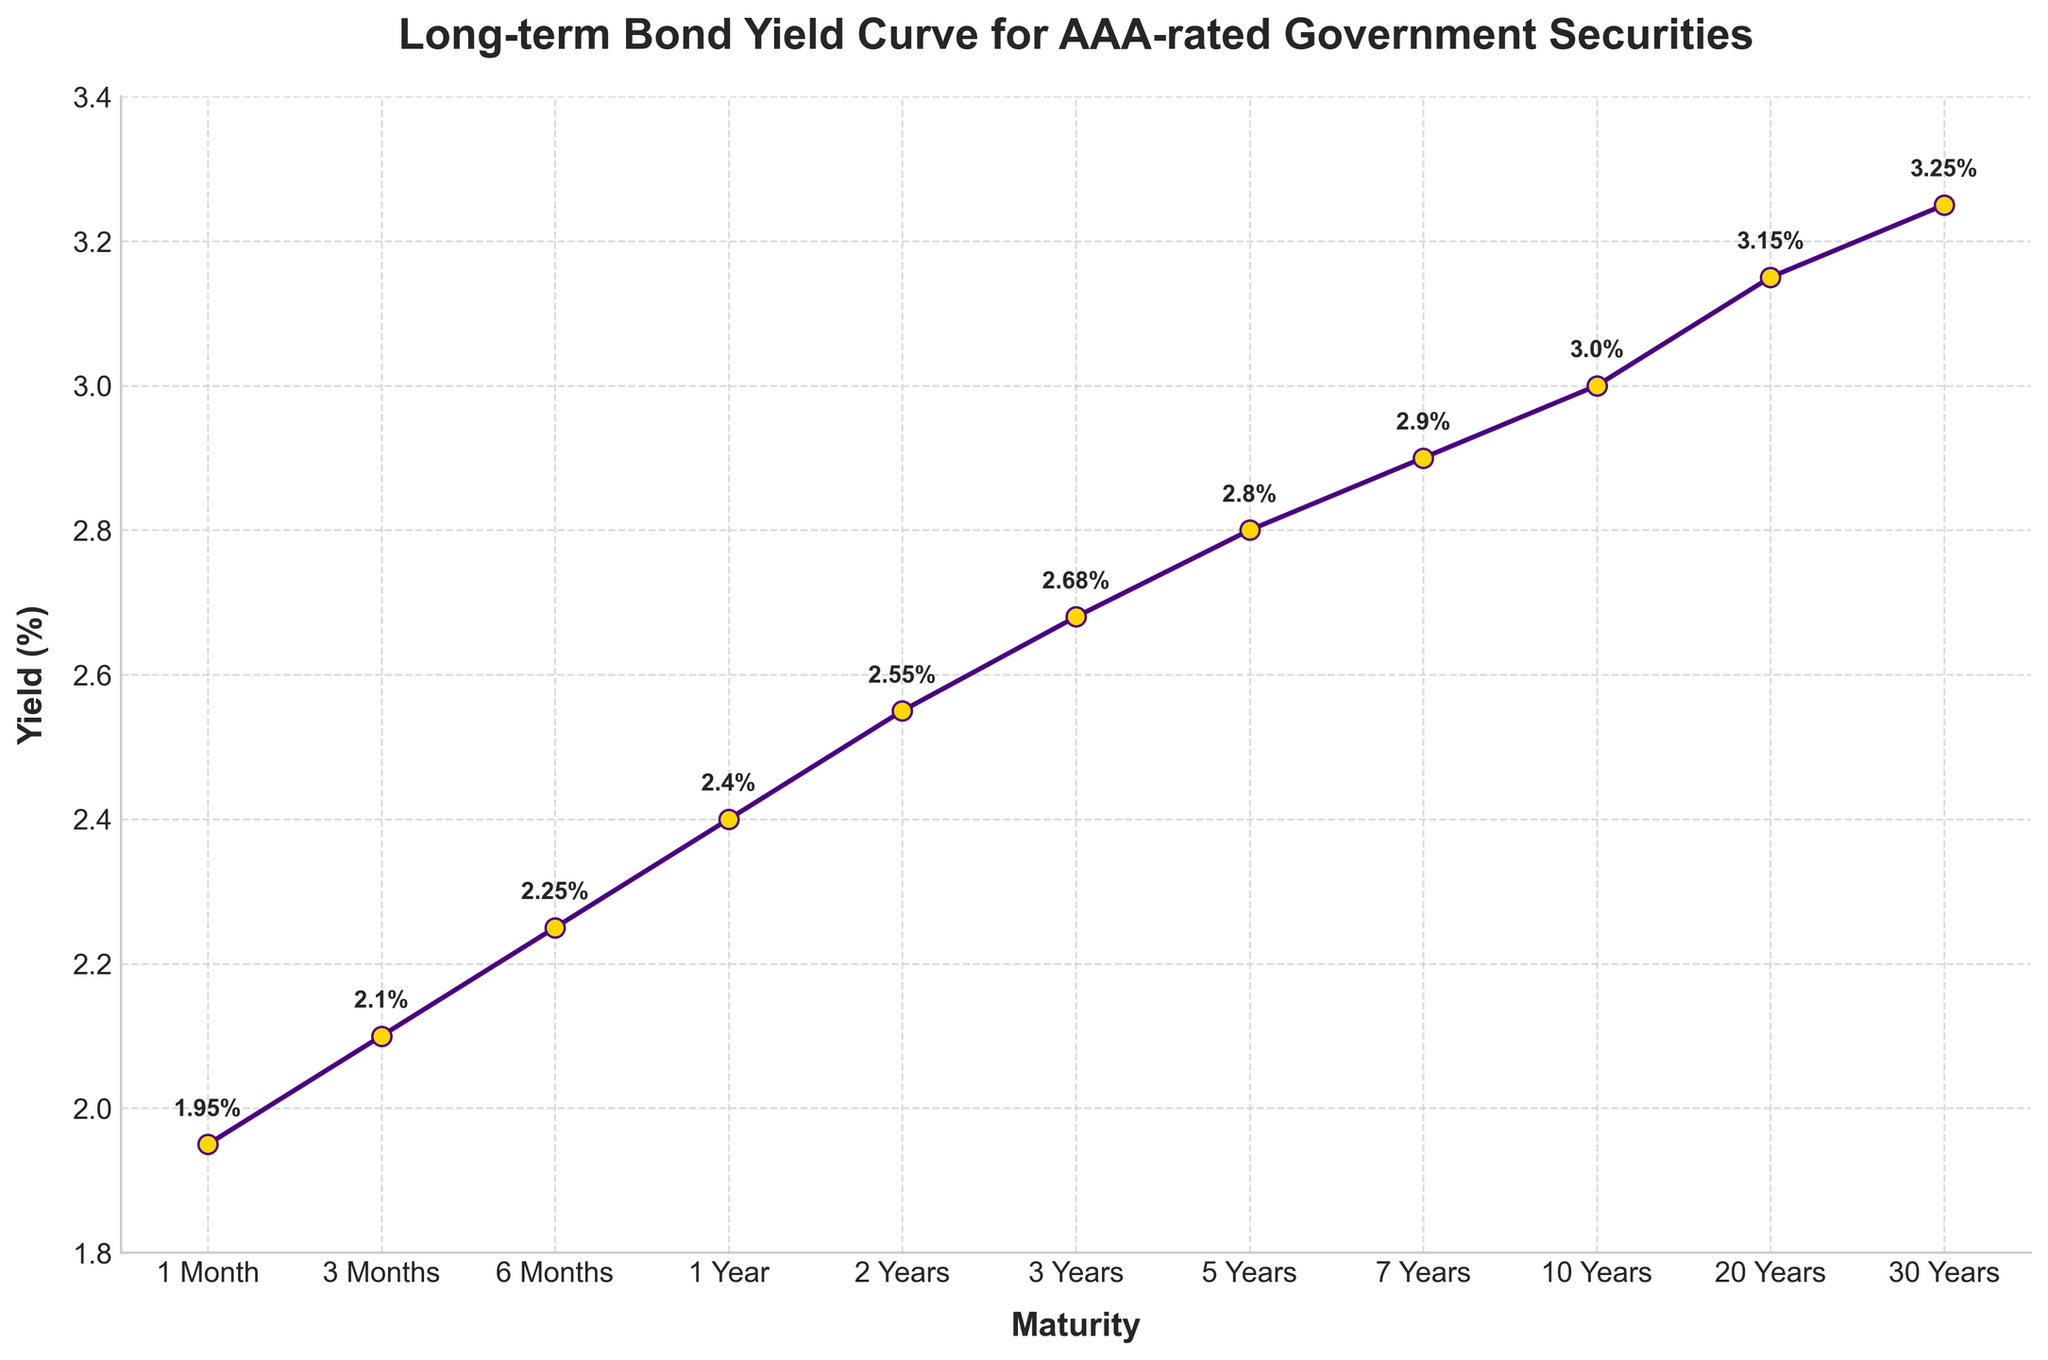What's the yield for a 10-year maturity? The 10-year maturity point on the x-axis corresponds to a data point on the y-axis. By checking this data point, we see that the yield is 3.00%.
Answer: 3.00% Which maturity has the highest yield? By tracing the line chart, we can see that the highest yield value is 3.25%, which corresponds to the 30 Years maturity.
Answer: 30 Years Which maturity has a lower yield: 1 Year or 5 Years? Compare the yield values of 1 Year (2.40%) and 5 Years (2.80%). Since 2.40% is less than 2.80%, the 1 Year maturity has a lower yield.
Answer: 1 Year What is the difference in yield between the 1 Month and 20 Years maturities? Subtract the yield of 1 Month (1.95%) from that of 20 Years (3.15%). The difference is 3.15% - 1.95% = 1.20%.
Answer: 1.20% Which maturity period has yields exactly between the yields of 6 Months and 3 Years? The yields for 6 Months and 3 Years are 2.25% and 2.68%, respectively. The maturity period that fits this criterion is 2 Years with a yield of 2.55%.
Answer: 2 Years What is the average yield for maturities of 1, 2, and 3 Years? Sum up the yields of 1 Year (2.40%), 2 Years (2.55%), and 3 Years (2.68%). The total is 2.40 + 2.55 + 2.68 = 7.63. Dividing by the number of maturities (3), we get 7.63 / 3 = 2.5433%.
Answer: 2.5433% How much does the yield increase from 7 Years to 30 Years? The yield for 7 Years is 2.90% and for 30 Years is 3.25%. The increase is calculated as 3.25% - 2.90% = 0.35%.
Answer: 0.35% Is the yield curve increasing or decreasing across the maturities? By observing the yield values from 1 Month to 30 Years, we see that the yields are consistently increasing as the maturity period increases.
Answer: Increasing What is the median yield value across all maturities? To find the median, list the yields in numerical order: (1.95%, 2.10%, 2.25%, 2.40%, 2.55%, 2.68%, 2.80%, 2.90%, 3.00%, 3.15%, 3.25%). The median value is the 6th value in this list, which is 2.68%.
Answer: 2.68% Compare the yield of the 1 Year maturity with the midpoint between the yields of 10 and 30 Years maturities. Which is higher? First, find the midpoint between 10 Years (3.00%) and 30 Years (3.25%): (3.00% + 3.25%) / 2 = 3.125%. By comparing, 3.125% (midpoint) is greater than 2.40% (1 Year).
Answer: Midpoint is higher 